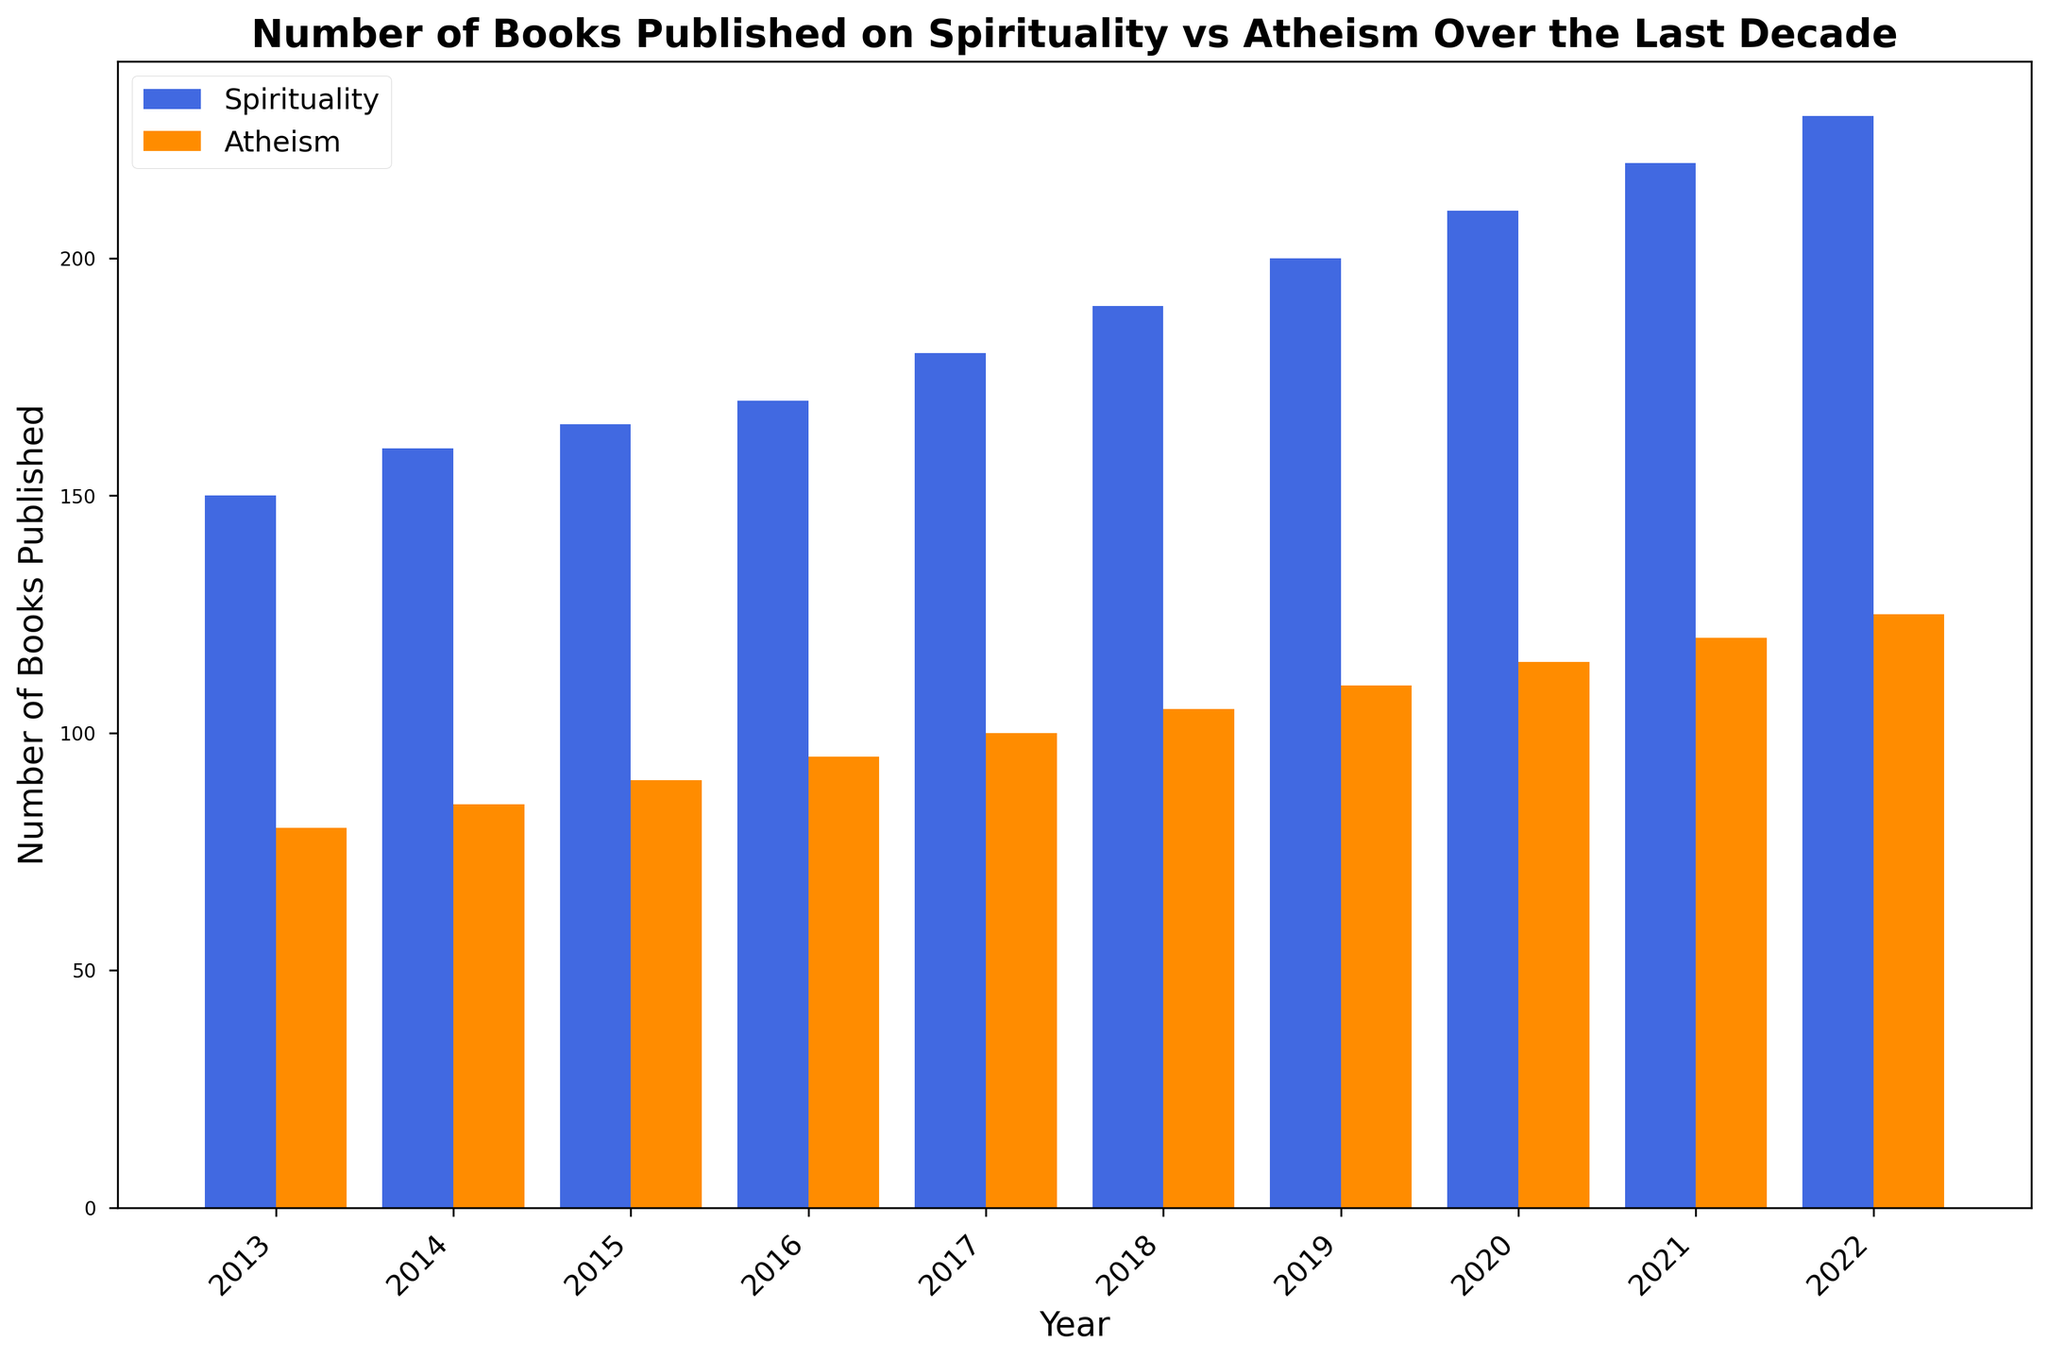What's the total number of books published on Spirituality and Atheism in 2018? To find the total number of books published on both topics in 2018, simply add the number of books published on Spirituality in 2018 (190) with the number of books published on Atheism in 2018 (105). So, the total is 190 + 105 = 295.
Answer: 295 Which year saw the greatest difference between the number of books published on Spirituality and Atheism? To find the year with the greatest difference, calculate the differences for each year and compare them. The differences are as follows: 2013: 70, 2014: 75, 2015: 75, 2016: 75, 2017: 80, 2018: 85, 2019: 90, 2020: 95, 2021: 100, 2022: 105. The greatest difference occurs in 2022 (230 - 125 = 105).
Answer: 2022 How did the number of books published on Spirituality change from 2013 to 2022? To find how the number of books changed, subtract the number of books published on Spirituality in 2013 (150) from the number published in 2022 (230). The change is 230 - 150 = 80.
Answer: Increased by 80 In which years were more than 200 books on Spirituality published? Checking the data for years where book publications on Spirituality were above 200: 2021 (220) and 2022 (230).
Answer: 2021, 2022 By how much did the number of books on Atheism increase from 2013 to 2018? To find the increase, subtract the number of books published in 2013 (80) from the number published in 2018 (105). The increase is 105 - 80 = 25.
Answer: 25 How many more books on Spirituality than Atheism were published in 2020? Subtract the number of Atheism books published in 2020 (115) from the Spirituality books published in 2020 (210). The difference is 210 - 115 = 95.
Answer: 95 Which year had the smallest number of books published on Spirituality? Look for the smallest value in the Spirituality column. The smallest number is 150 in the year 2013.
Answer: 2013 